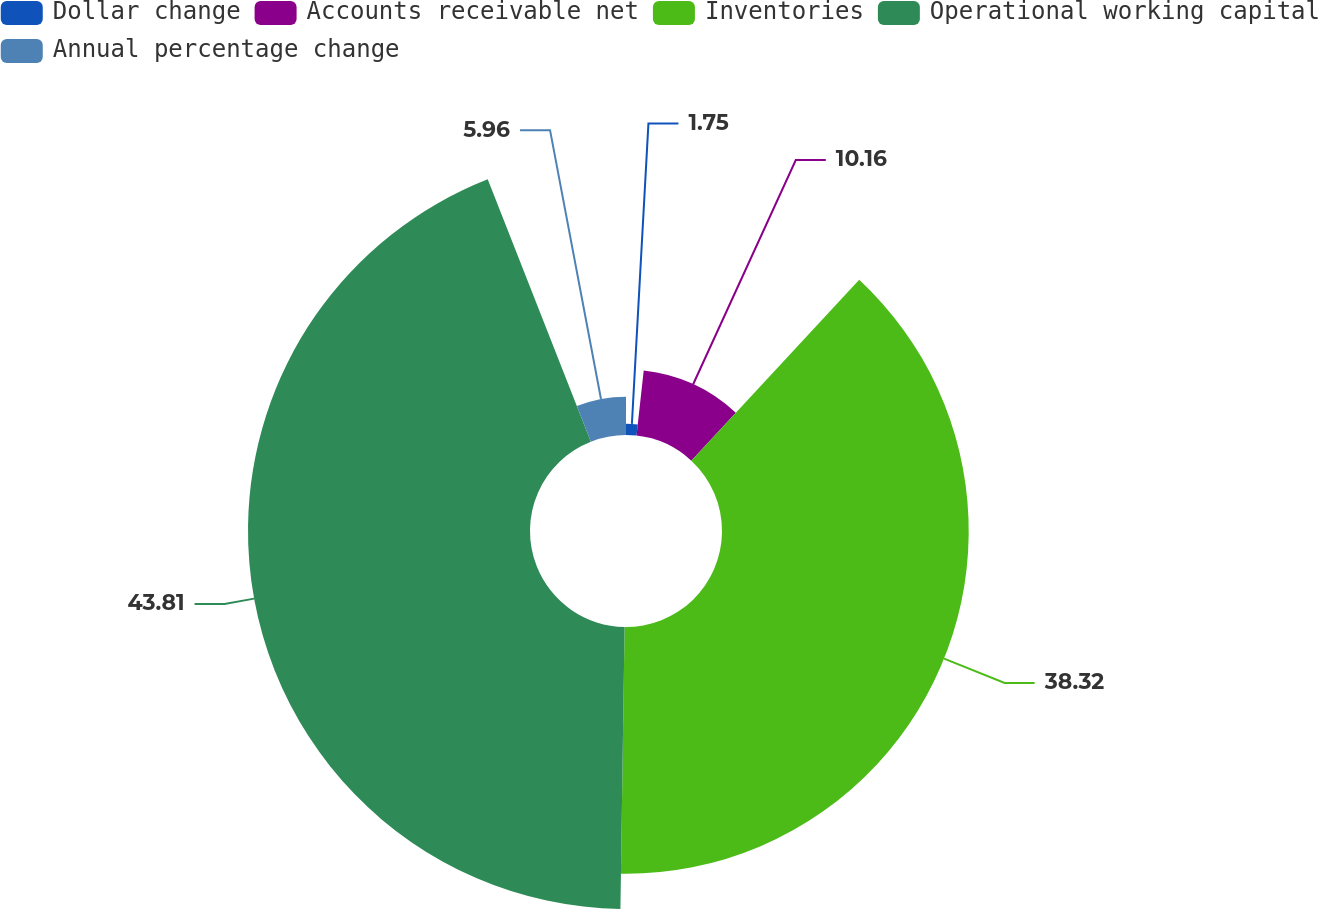Convert chart. <chart><loc_0><loc_0><loc_500><loc_500><pie_chart><fcel>Dollar change<fcel>Accounts receivable net<fcel>Inventories<fcel>Operational working capital<fcel>Annual percentage change<nl><fcel>1.75%<fcel>10.16%<fcel>38.32%<fcel>43.8%<fcel>5.96%<nl></chart> 